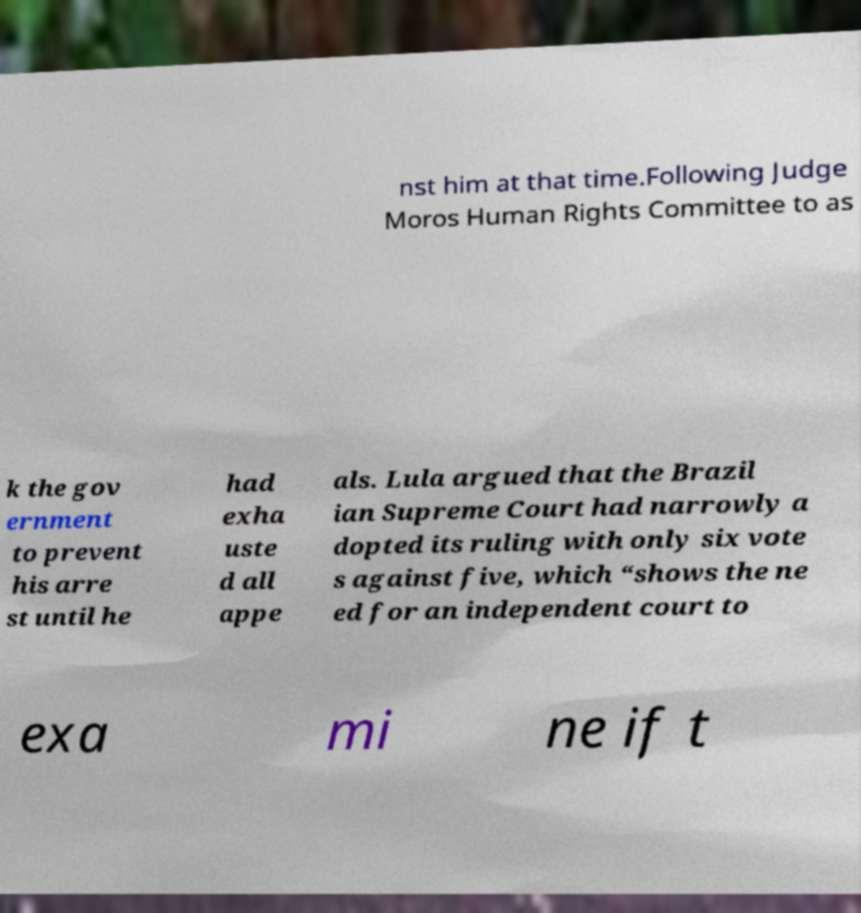Please identify and transcribe the text found in this image. nst him at that time.Following Judge Moros Human Rights Committee to as k the gov ernment to prevent his arre st until he had exha uste d all appe als. Lula argued that the Brazil ian Supreme Court had narrowly a dopted its ruling with only six vote s against five, which “shows the ne ed for an independent court to exa mi ne if t 